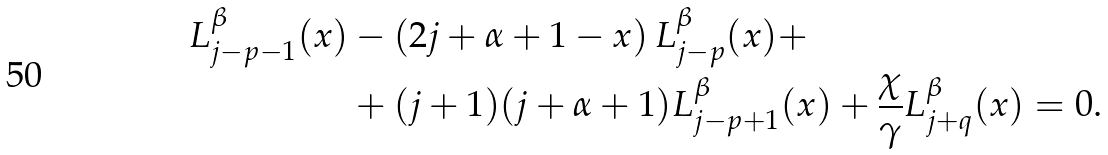<formula> <loc_0><loc_0><loc_500><loc_500>L ^ { \beta } _ { j - p - 1 } ( x ) & - \left ( 2 j + \alpha + 1 - x \right ) L ^ { \beta } _ { j - p } ( x ) + \\ & + ( j + 1 ) ( j + \alpha + 1 ) L ^ { \beta } _ { j - p + 1 } ( x ) + \frac { \chi } { \gamma } L ^ { \beta } _ { j + q } ( x ) = 0 .</formula> 